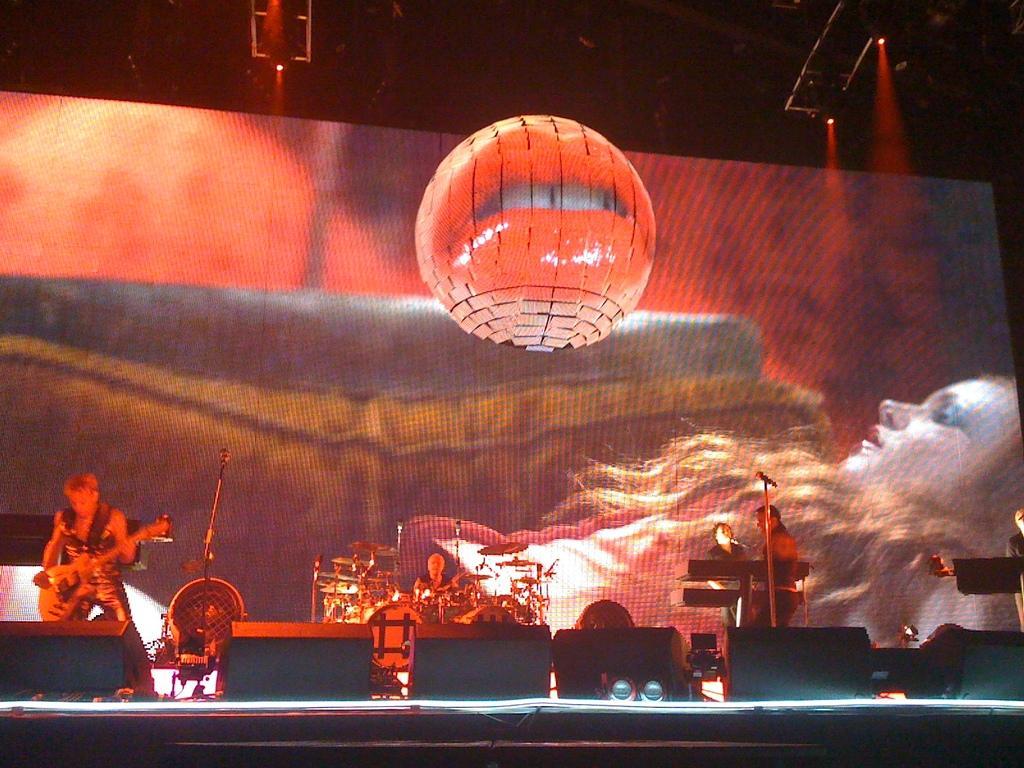Could you give a brief overview of what you see in this image? In this picture there is a man who is playing a guitar. He is standing on the stage. In the center of the stage I can see the man who is playing the drums. On the right there are two women who are standing near to the speech desk and mic. In the background I can see the screen. In that screen I can see the woman face. At the top I can see the roof of the shed. In the center of the picture there is a balloon. At the bottom I can see the speakers. 